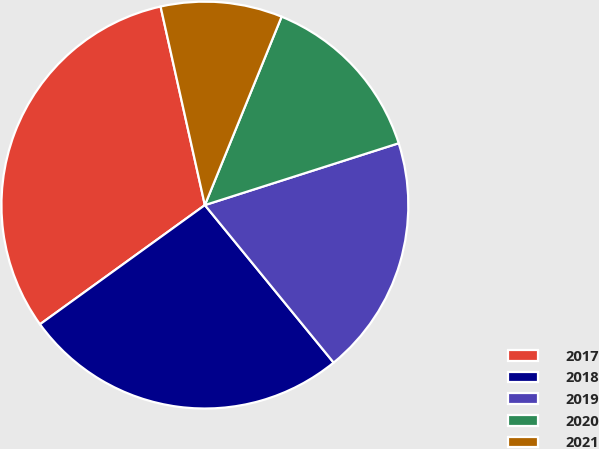<chart> <loc_0><loc_0><loc_500><loc_500><pie_chart><fcel>2017<fcel>2018<fcel>2019<fcel>2020<fcel>2021<nl><fcel>31.47%<fcel>25.95%<fcel>19.01%<fcel>13.93%<fcel>9.65%<nl></chart> 